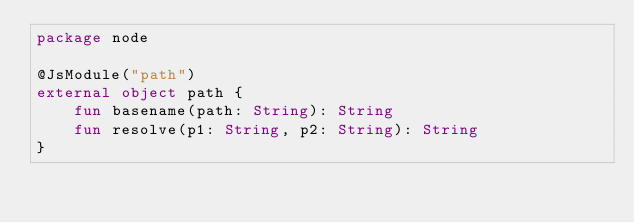Convert code to text. <code><loc_0><loc_0><loc_500><loc_500><_Kotlin_>package node

@JsModule("path")
external object path {
    fun basename(path: String): String
    fun resolve(p1: String, p2: String): String
}

</code> 